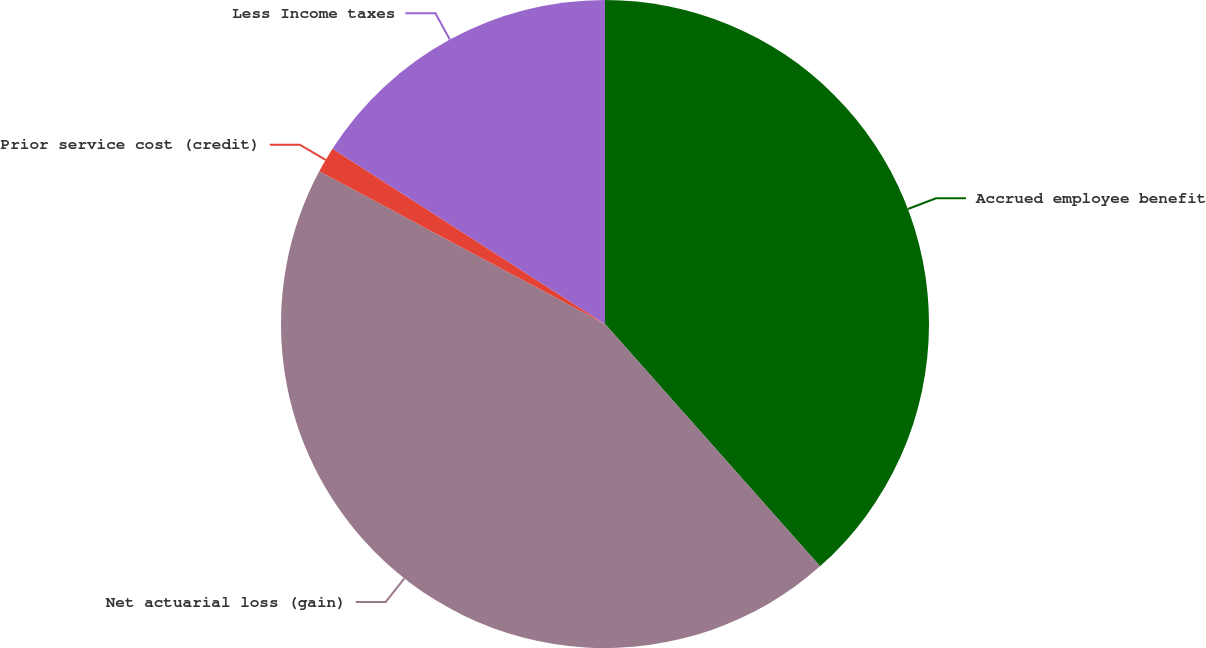<chart> <loc_0><loc_0><loc_500><loc_500><pie_chart><fcel>Accrued employee benefit<fcel>Net actuarial loss (gain)<fcel>Prior service cost (credit)<fcel>Less Income taxes<nl><fcel>38.45%<fcel>44.36%<fcel>1.29%<fcel>15.9%<nl></chart> 